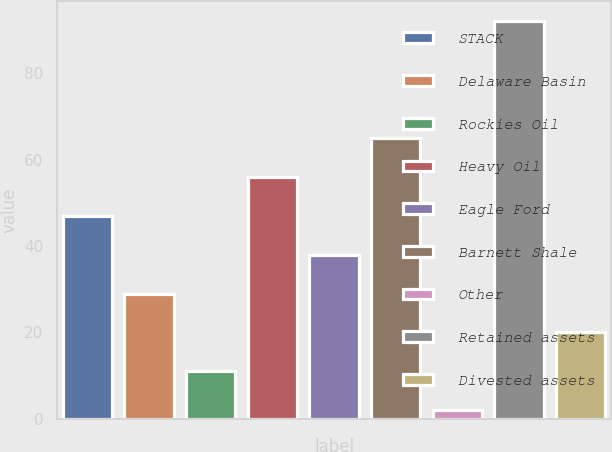<chart> <loc_0><loc_0><loc_500><loc_500><bar_chart><fcel>STACK<fcel>Delaware Basin<fcel>Rockies Oil<fcel>Heavy Oil<fcel>Eagle Ford<fcel>Barnett Shale<fcel>Other<fcel>Retained assets<fcel>Divested assets<nl><fcel>47<fcel>29<fcel>11<fcel>56<fcel>38<fcel>65<fcel>2<fcel>92<fcel>20<nl></chart> 